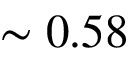<formula> <loc_0><loc_0><loc_500><loc_500>\sim 0 . 5 8</formula> 